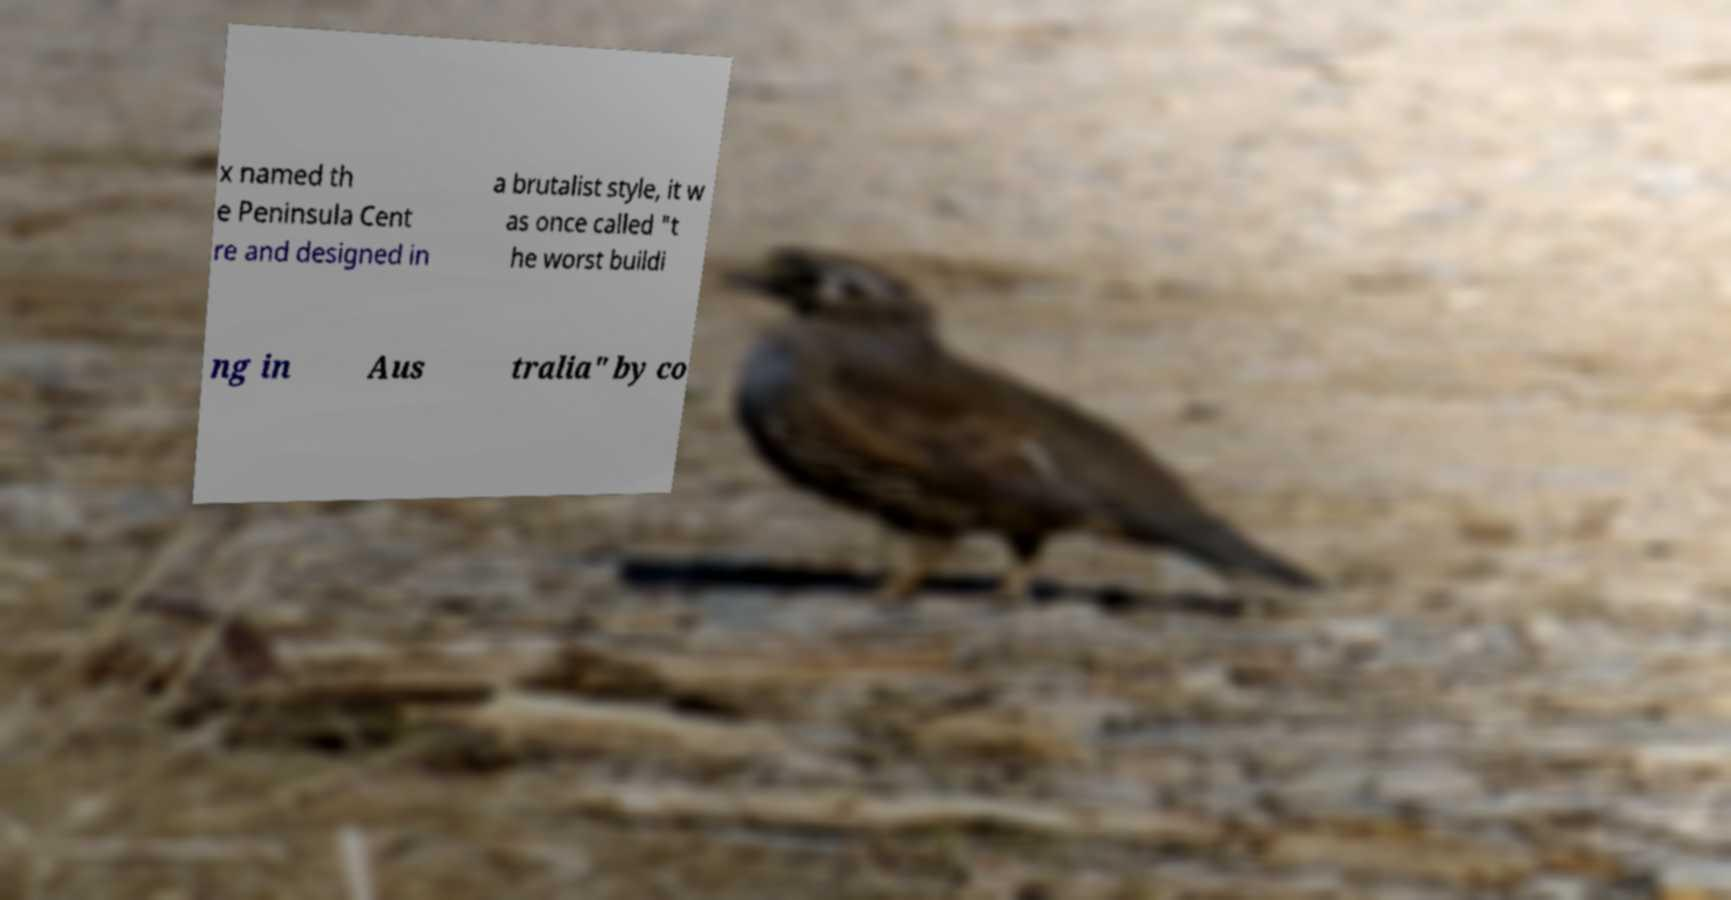I need the written content from this picture converted into text. Can you do that? x named th e Peninsula Cent re and designed in a brutalist style, it w as once called "t he worst buildi ng in Aus tralia" by co 